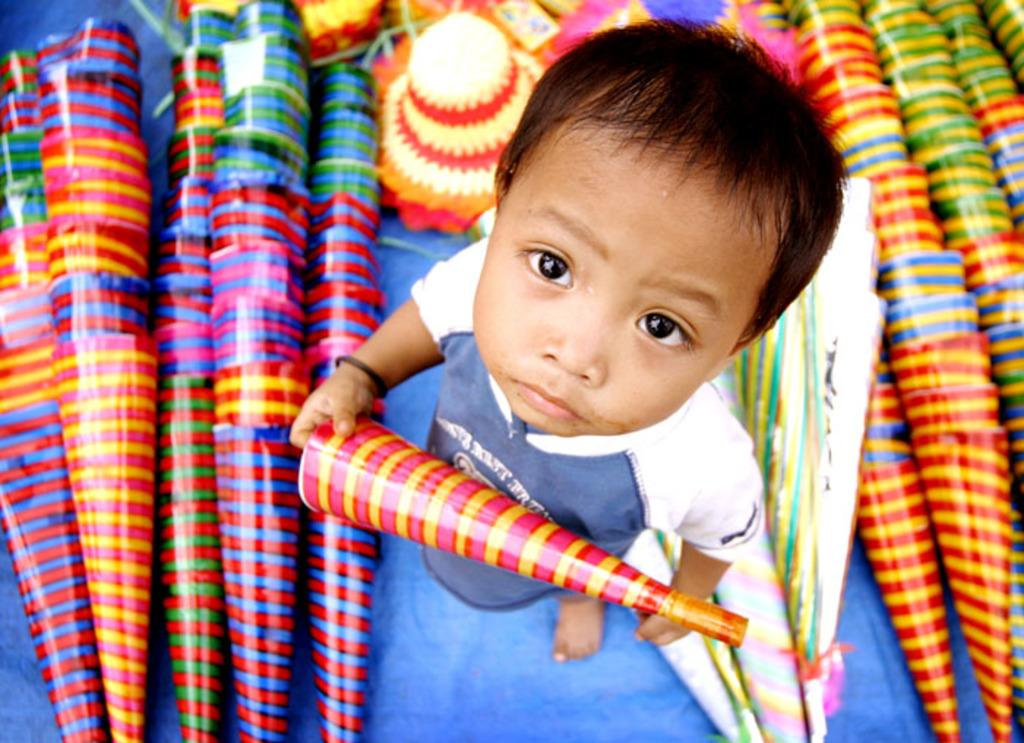What is the main subject of the image? There is a kid in the image. What is the kid holding in the image? The kid is holding an object. Can you describe any other objects visible in the image? There are visible in the background of the image? What type of polish is the kid applying to the objects in the image? There is no indication in the image that the kid is applying any polish to any objects. 